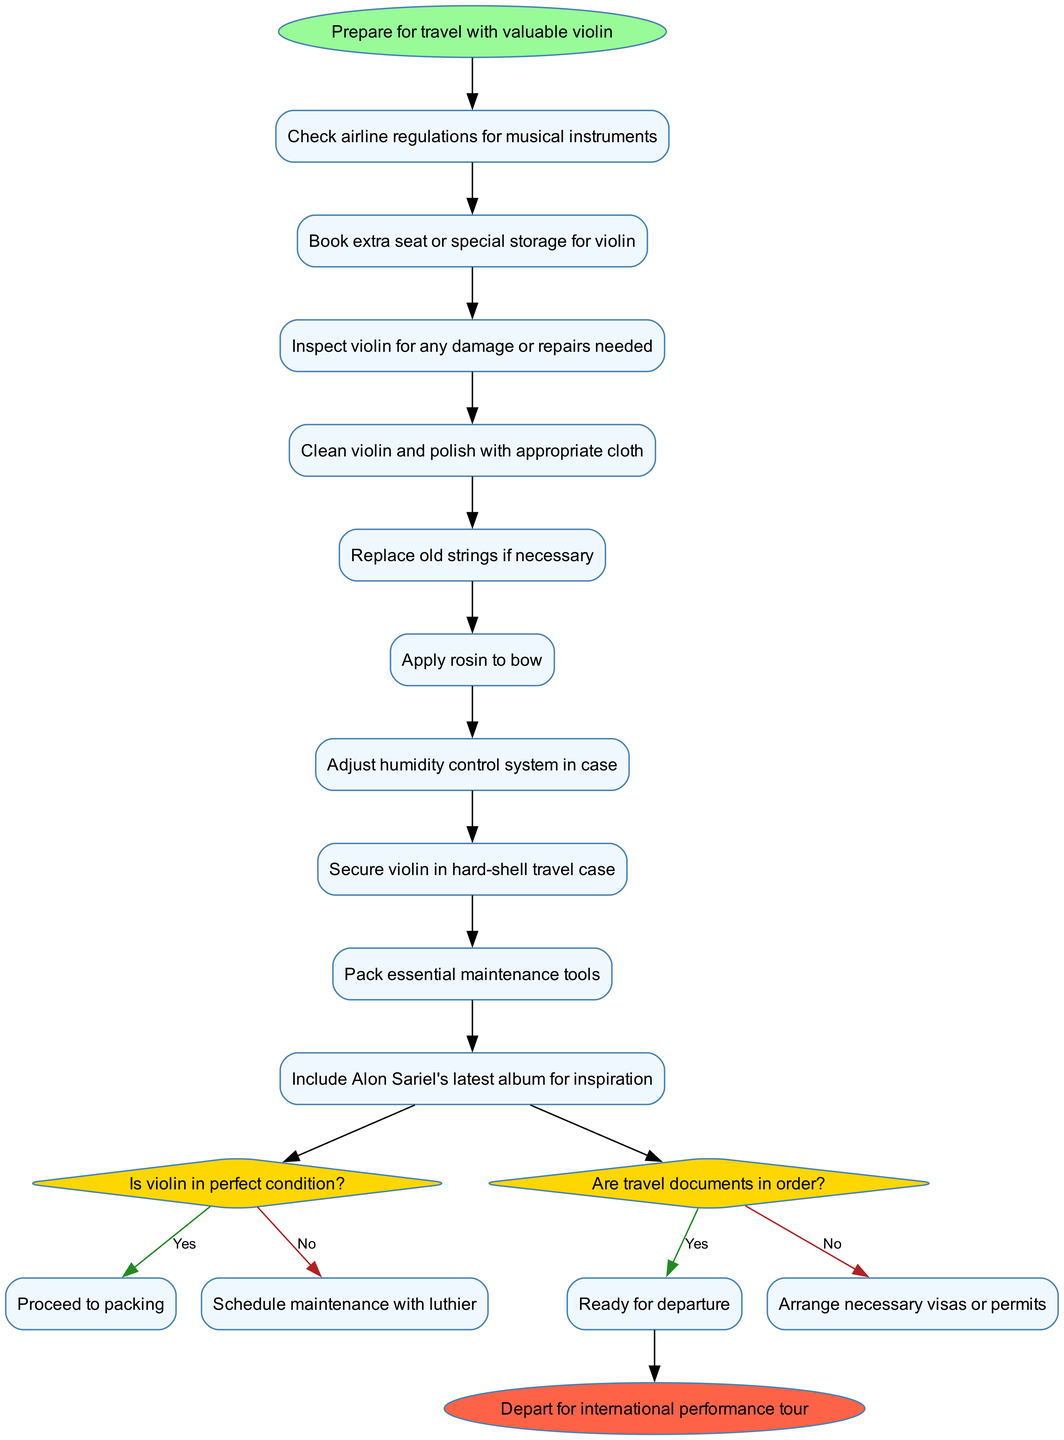What is the starting point of the diagram? The starting point is defined as "Prepare for travel with valuable violin". This is indicated as the first node in the diagram.
Answer: Prepare for travel with valuable violin How many activities are listed in the diagram? The diagram contains ten activities, each represented as a node in the sequence of actions to prepare for travel.
Answer: 10 What do you do if the violin is not in perfect condition? If the violin is not in perfect condition, the diagram instructs to "Schedule maintenance with luthier." This follows directly from the decision node regarding the violin's condition.
Answer: Schedule maintenance with luthier What is the last activity before making a decision in the diagram? The last activity before making a decision is "Secure violin in hard-shell travel case". This is the final step prior to the decision on the violin's condition.
Answer: Secure violin in hard-shell travel case What happens if travel documents are not in order? If travel documents are not in order, the diagram states to "Arrange necessary visas or permits." This is from the decision node related to the travel documents.
Answer: Arrange necessary visas or permits Which activity requires adjusting the humidity control system? The activity that requires adjusting the humidity control system is "Adjust humidity control system in case." It is one of the necessary preparations for the violin's care.
Answer: Adjust humidity control system in case How many decision nodes are in the diagram? There are two decision nodes present in the diagram. They are used to determine the condition of the violin and the state of travel documents.
Answer: 2 What should you pack for travel alongside the violin? The diagram mentions to "Pack essential maintenance tools." This ensures that appropriate tools for maintenance are available during travel.
Answer: Pack essential maintenance tools What is the final step in the preparation process? The final step in the preparation process is "Depart for international performance tour." This indicates the conclusion of all preceding activities and decisions.
Answer: Depart for international performance tour 